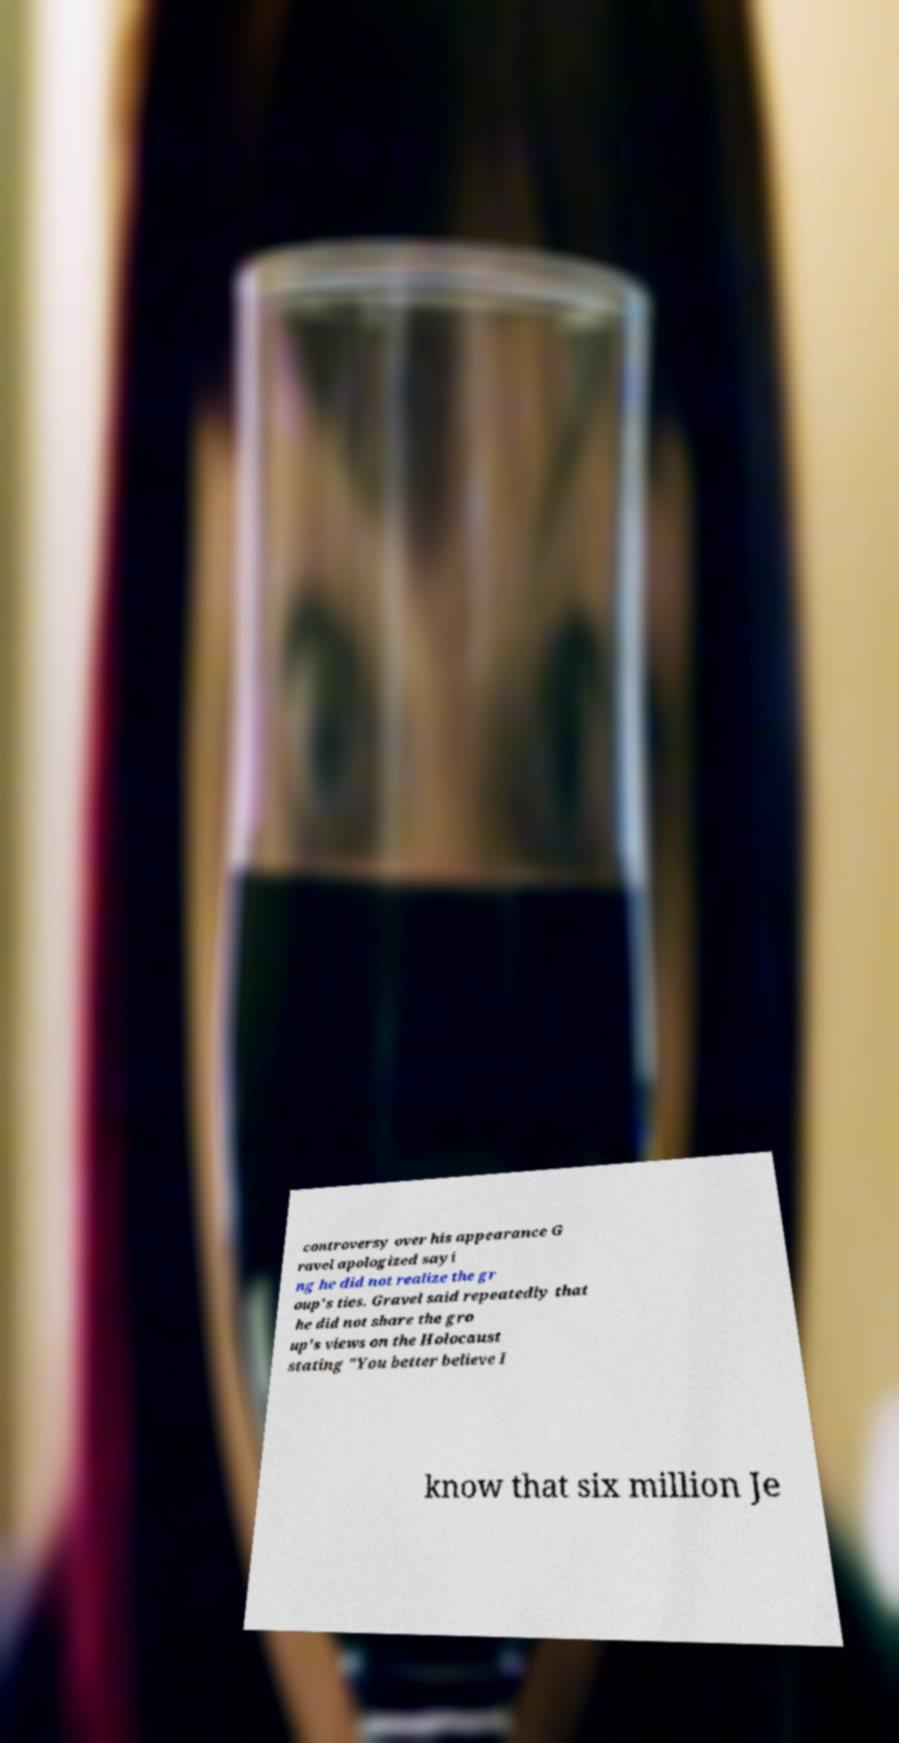Could you assist in decoding the text presented in this image and type it out clearly? controversy over his appearance G ravel apologized sayi ng he did not realize the gr oup's ties. Gravel said repeatedly that he did not share the gro up's views on the Holocaust stating "You better believe I know that six million Je 